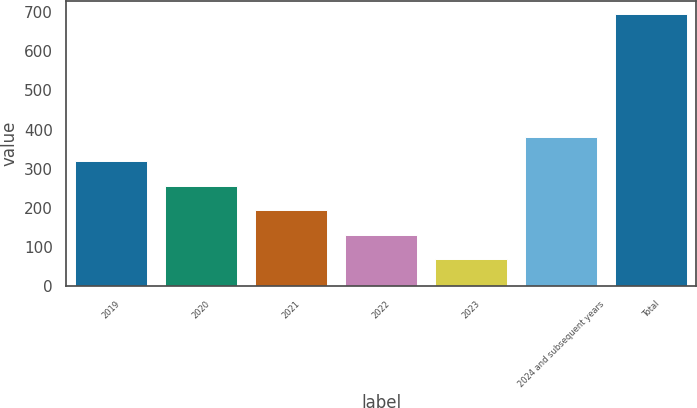Convert chart to OTSL. <chart><loc_0><loc_0><loc_500><loc_500><bar_chart><fcel>2019<fcel>2020<fcel>2021<fcel>2022<fcel>2023<fcel>2024 and subsequent years<fcel>Total<nl><fcel>319.4<fcel>256.8<fcel>194.2<fcel>131.6<fcel>69<fcel>382<fcel>695<nl></chart> 